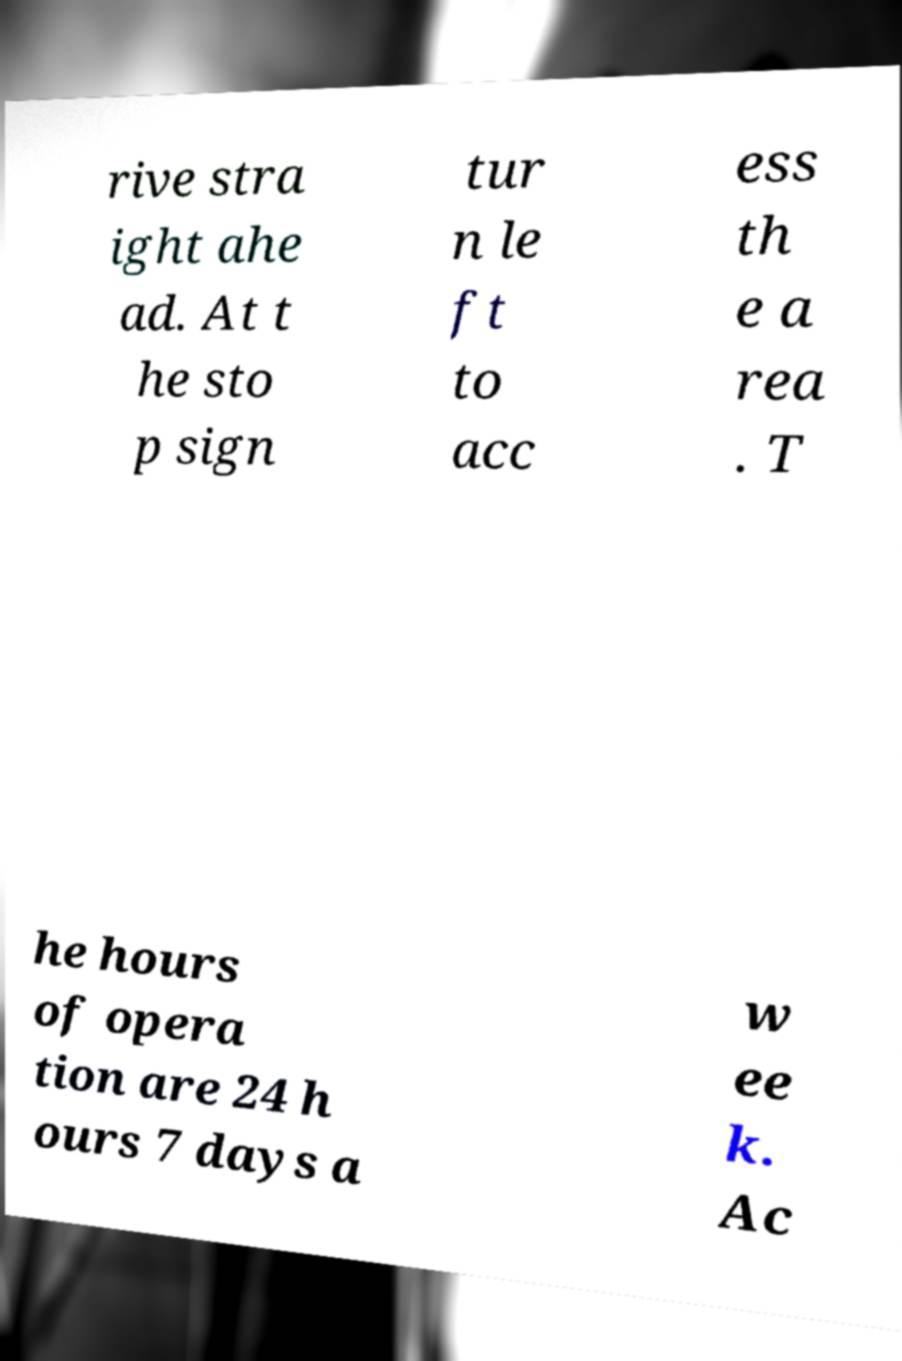Please identify and transcribe the text found in this image. rive stra ight ahe ad. At t he sto p sign tur n le ft to acc ess th e a rea . T he hours of opera tion are 24 h ours 7 days a w ee k. Ac 